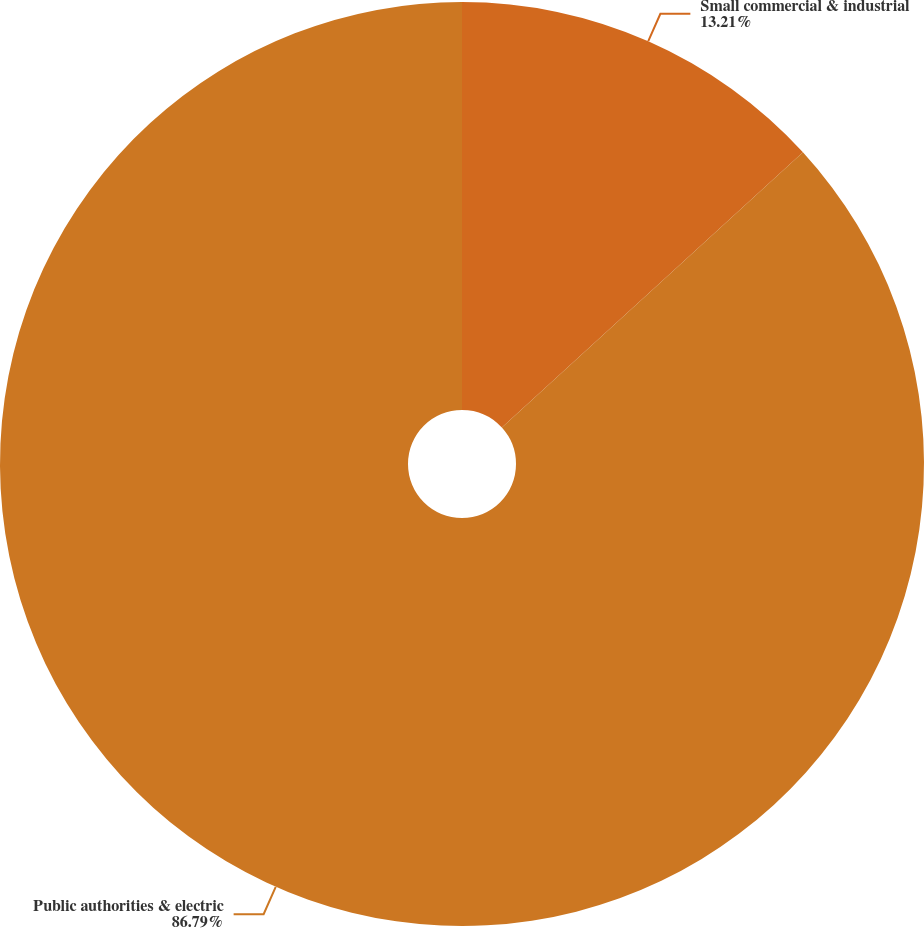<chart> <loc_0><loc_0><loc_500><loc_500><pie_chart><fcel>Small commercial & industrial<fcel>Public authorities & electric<nl><fcel>13.21%<fcel>86.79%<nl></chart> 